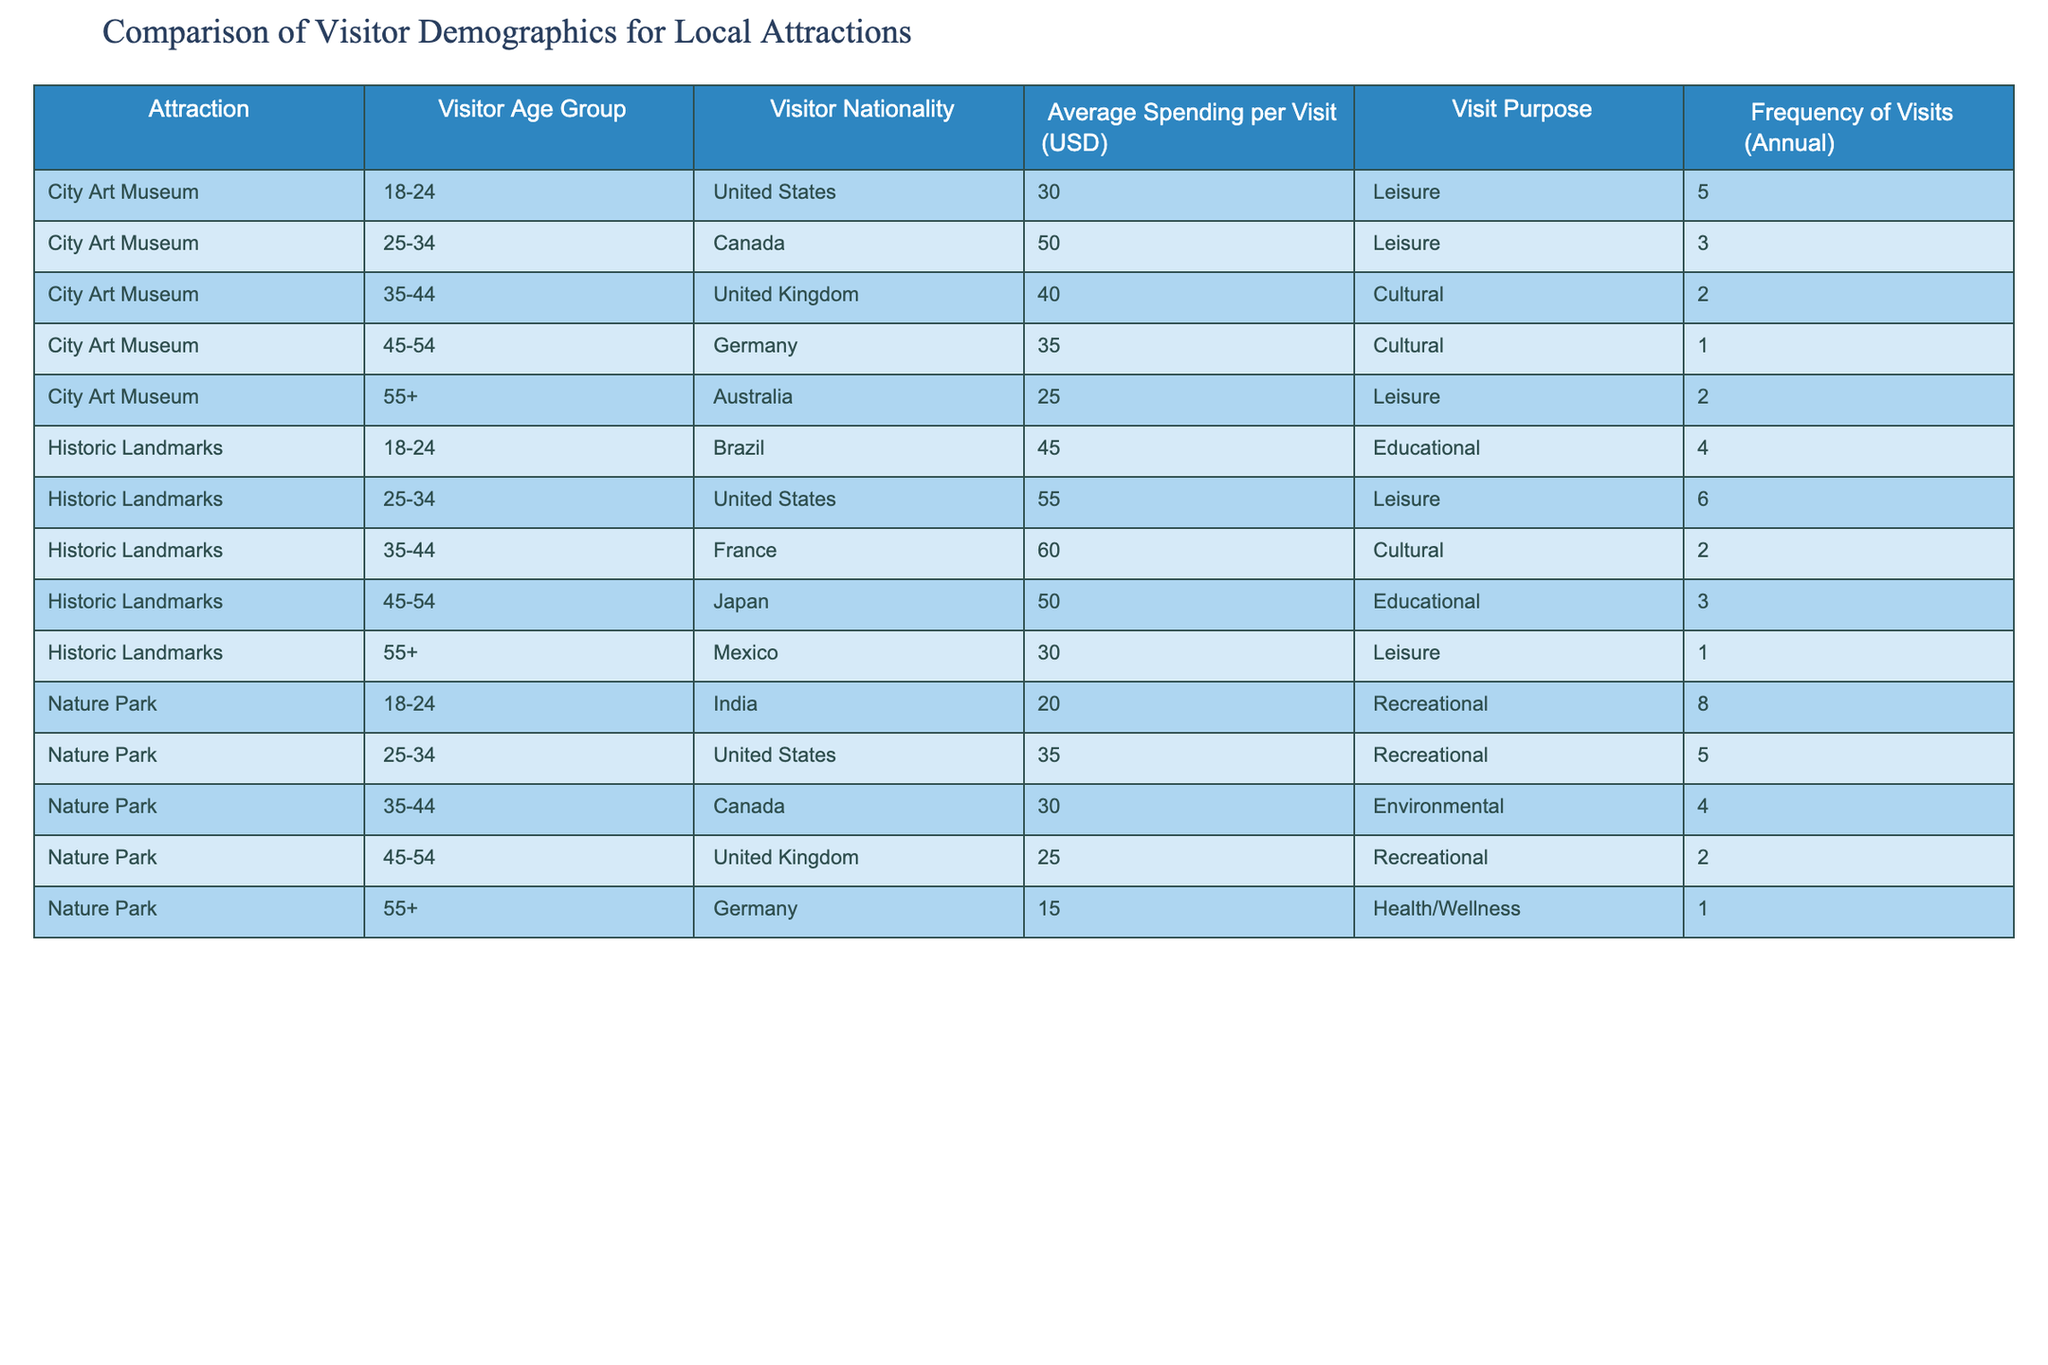What is the average spending per visit for visitors aged 25-34 at the City Art Museum? For visitors aged 25-34 at the City Art Museum, their average spending per visit is 50 USD. This value is taken directly from the table.
Answer: 50 USD How many different nationalities are represented among visitors to the Historic Landmarks? There are five different nationalities reported in the table for the Historic Landmarks (Brazil, United States, France, Japan, Mexico). This is counted directly from the rows specific to the Historic Landmarks in the table.
Answer: 5 What is the total frequency of visits for the Nature Park from the age group 18-24? The frequency of visits for the Nature Park from the age group 18-24 is 8, which is directly taken from the table.
Answer: 8 Is there any visitor nationality that doesn’t spend over 30 USD at the City Art Museum? Yes, the visitor from Australia aged 55+ spends 25 USD, which is under 30 USD. This is observed in the table under the City Art Museum section.
Answer: Yes Which attraction has the highest average spending per visit in the 35-44 age group? The Historic Landmarks has the highest average spending per visit in the 35-44 age group with 60 USD, compared to 40 USD at the City Art Museum and 30 USD at the Nature Park. Comparing the values for this age group across all attractions leads to this conclusion.
Answer: Historic Landmarks What is the average spending per visit for the age group 45-54 across all attractions? For the age group 45-54, the spending is as follows: City Art Museum - 35 USD, Historic Landmarks - 50 USD, and Nature Park - 25 USD. The average is calculated as (35 + 50 + 25) / 3 = 36.67 USD when summing and dividing by the total number of attractions.
Answer: 36.67 USD How many countries are represented in the Nature Park's visitor demographics? The Nature Park has visitors from four countries: India, United States, Canada, and Germany. This is established by counting the distinct nationalities listed in the respective rows for the Nature Park in the table.
Answer: 4 Do all visitors aged 55 and older spend less than 30 USD at the Historic Landmarks? No, the visitor from Japan spends 50 USD, which exceeds 30 USD. This can be confirmed by checking the average spending of the 55+ age group for this attraction in the table.
Answer: No 